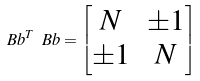<formula> <loc_0><loc_0><loc_500><loc_500>\ B b ^ { T } \ B b = \begin{bmatrix} N & \pm 1 \\ \pm 1 & N \end{bmatrix}</formula> 